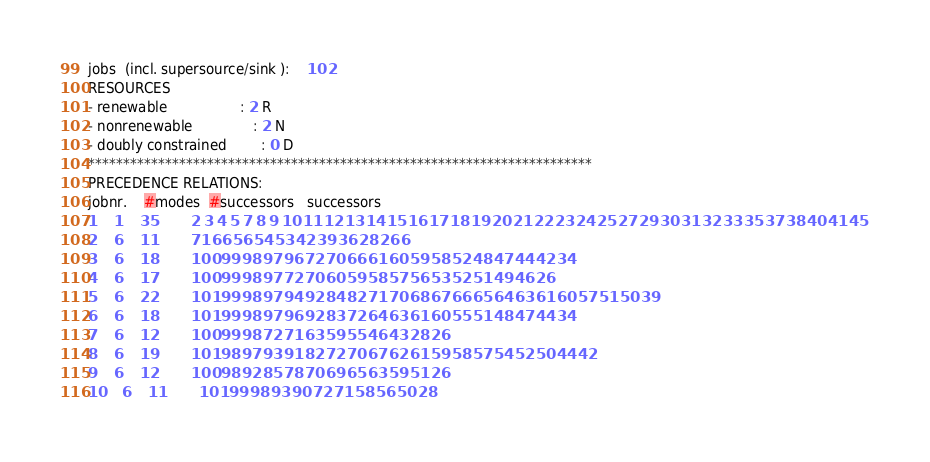Convert code to text. <code><loc_0><loc_0><loc_500><loc_500><_ObjectiveC_>jobs  (incl. supersource/sink ):	102
RESOURCES
- renewable                 : 2 R
- nonrenewable              : 2 N
- doubly constrained        : 0 D
************************************************************************
PRECEDENCE RELATIONS:
jobnr.    #modes  #successors   successors
1	1	35		2 3 4 5 7 8 9 10 11 12 13 14 15 16 17 18 19 20 21 22 23 24 25 27 29 30 31 32 33 35 37 38 40 41 45 
2	6	11		71 66 56 54 53 42 39 36 28 26 6 
3	6	18		100 99 98 97 96 72 70 66 61 60 59 58 52 48 47 44 42 34 
4	6	17		100 99 98 97 72 70 60 59 58 57 56 53 52 51 49 46 26 
5	6	22		101 99 98 97 94 92 84 82 71 70 68 67 66 65 64 63 61 60 57 51 50 39 
6	6	18		101 99 98 97 96 92 83 72 64 63 61 60 55 51 48 47 44 34 
7	6	12		100 99 98 72 71 63 59 55 46 43 28 26 
8	6	19		101 98 97 93 91 82 72 70 67 62 61 59 58 57 54 52 50 44 42 
9	6	12		100 98 92 85 78 70 69 65 63 59 51 26 
10	6	11		101 99 98 93 90 72 71 58 56 50 28 </code> 